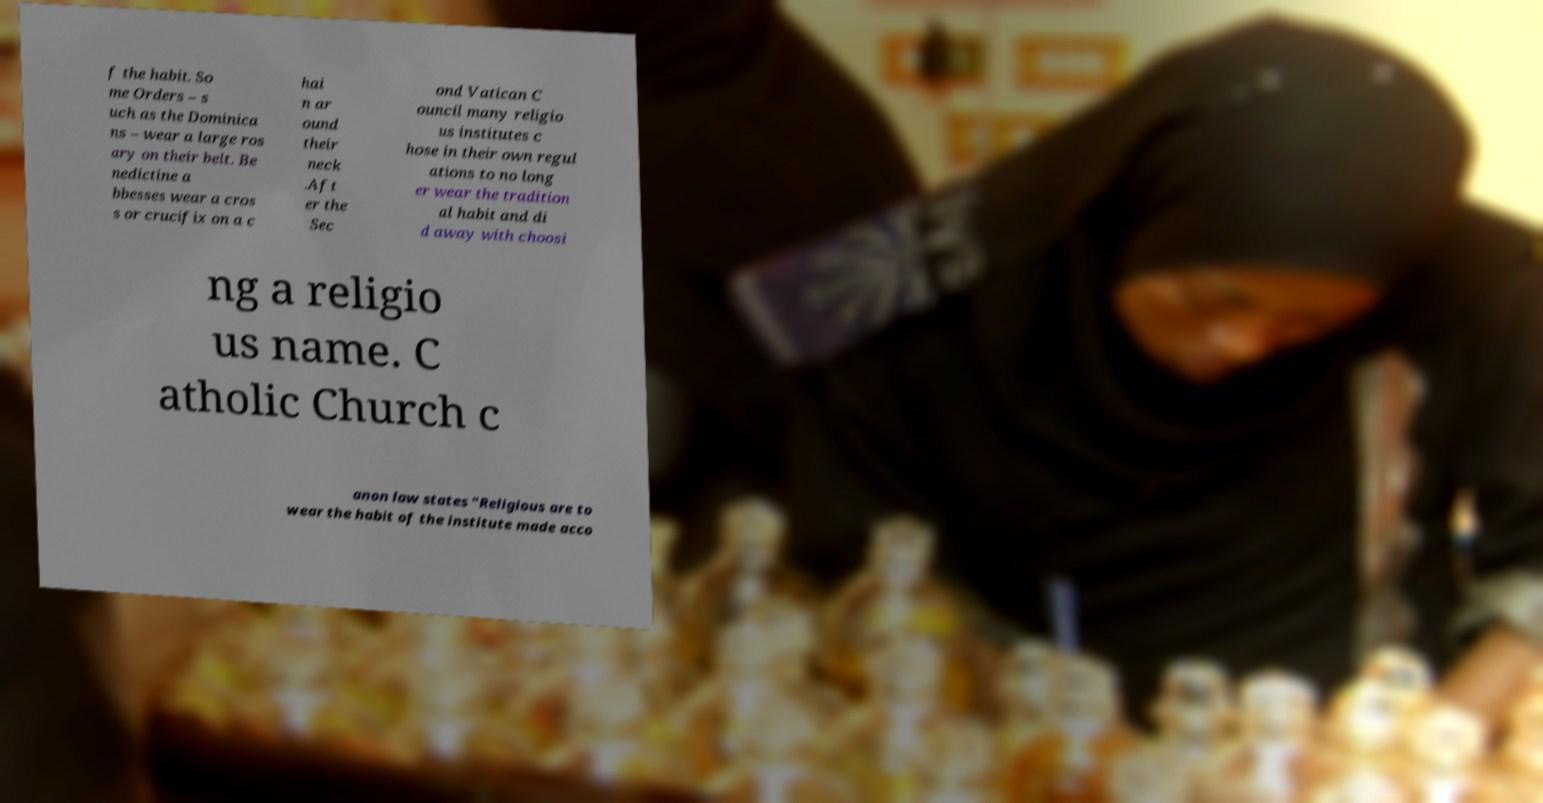I need the written content from this picture converted into text. Can you do that? f the habit. So me Orders – s uch as the Dominica ns – wear a large ros ary on their belt. Be nedictine a bbesses wear a cros s or crucifix on a c hai n ar ound their neck .Aft er the Sec ond Vatican C ouncil many religio us institutes c hose in their own regul ations to no long er wear the tradition al habit and di d away with choosi ng a religio us name. C atholic Church c anon law states "Religious are to wear the habit of the institute made acco 